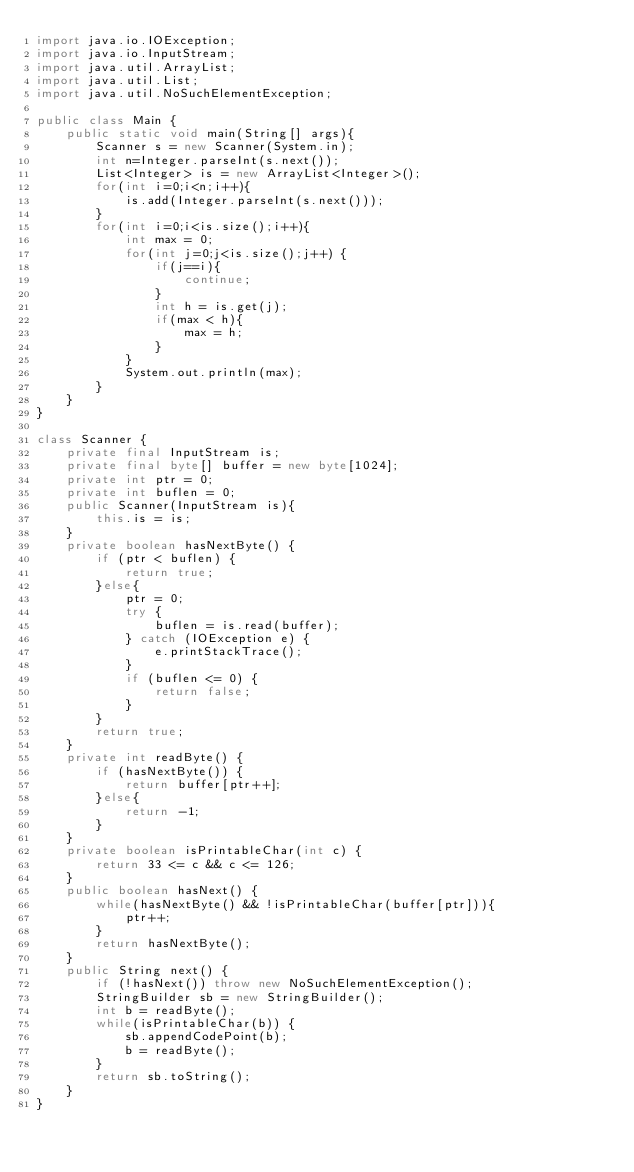Convert code to text. <code><loc_0><loc_0><loc_500><loc_500><_Java_>import java.io.IOException;
import java.io.InputStream;
import java.util.ArrayList;
import java.util.List;
import java.util.NoSuchElementException;

public class Main {
    public static void main(String[] args){
        Scanner s = new Scanner(System.in);
        int n=Integer.parseInt(s.next());
        List<Integer> is = new ArrayList<Integer>();
        for(int i=0;i<n;i++){
            is.add(Integer.parseInt(s.next()));
        }
        for(int i=0;i<is.size();i++){
            int max = 0;
            for(int j=0;j<is.size();j++) {
                if(j==i){
                    continue;
                }
                int h = is.get(j);
                if(max < h){
                    max = h;
                }
            }
            System.out.println(max);
        }
    }
}

class Scanner {
    private final InputStream is;
    private final byte[] buffer = new byte[1024];
    private int ptr = 0;
    private int buflen = 0;
    public Scanner(InputStream is){
        this.is = is;
    }
    private boolean hasNextByte() {
        if (ptr < buflen) {
            return true;
        }else{
            ptr = 0;
            try {
                buflen = is.read(buffer);
            } catch (IOException e) {
                e.printStackTrace();
            }
            if (buflen <= 0) {
                return false;
            }
        }
        return true;
    }
    private int readByte() {
        if (hasNextByte()) {
            return buffer[ptr++];
        }else{
            return -1;
        }
    }
    private boolean isPrintableChar(int c) {
        return 33 <= c && c <= 126;
    }
    public boolean hasNext() {
        while(hasNextByte() && !isPrintableChar(buffer[ptr])){
            ptr++;
        }
        return hasNextByte();
    }
    public String next() {
        if (!hasNext()) throw new NoSuchElementException();
        StringBuilder sb = new StringBuilder();
        int b = readByte();
        while(isPrintableChar(b)) {
            sb.appendCodePoint(b);
            b = readByte();
        }
        return sb.toString();
    }
}</code> 